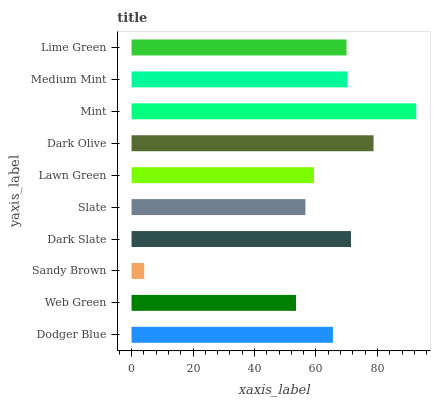Is Sandy Brown the minimum?
Answer yes or no. Yes. Is Mint the maximum?
Answer yes or no. Yes. Is Web Green the minimum?
Answer yes or no. No. Is Web Green the maximum?
Answer yes or no. No. Is Dodger Blue greater than Web Green?
Answer yes or no. Yes. Is Web Green less than Dodger Blue?
Answer yes or no. Yes. Is Web Green greater than Dodger Blue?
Answer yes or no. No. Is Dodger Blue less than Web Green?
Answer yes or no. No. Is Lime Green the high median?
Answer yes or no. Yes. Is Dodger Blue the low median?
Answer yes or no. Yes. Is Dark Slate the high median?
Answer yes or no. No. Is Sandy Brown the low median?
Answer yes or no. No. 